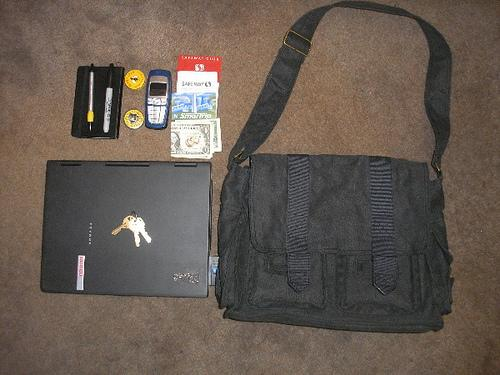What is on the laptop?

Choices:
A) butterfly
B) cat
C) egg
D) keys keys 